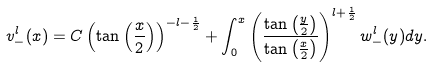<formula> <loc_0><loc_0><loc_500><loc_500>v _ { - } ^ { l } ( x ) = C \left ( \tan \left ( \frac { x } { 2 } \right ) \right ) ^ { - l - \frac { 1 } { 2 } } + \int _ { 0 } ^ { x } \left ( \frac { \tan \left ( \frac { y } { 2 } \right ) } { \tan \left ( \frac { x } { 2 } \right ) } \right ) ^ { l + \frac { 1 } { 2 } } w _ { - } ^ { l } ( y ) d y .</formula> 